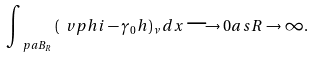<formula> <loc_0><loc_0><loc_500><loc_500>\int _ { \ p a B _ { R } } \, ( \ v p h i - \gamma _ { 0 } h ) _ { \nu } \, d x \longrightarrow 0 a s R \rightarrow \infty .</formula> 